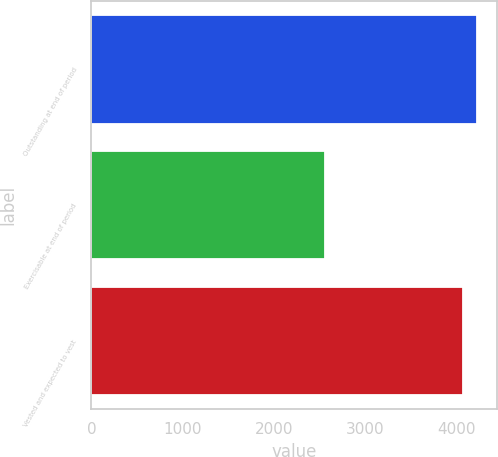Convert chart. <chart><loc_0><loc_0><loc_500><loc_500><bar_chart><fcel>Outstanding at end of period<fcel>Exercisable at end of period<fcel>Vested and expected to vest<nl><fcel>4227.4<fcel>2560<fcel>4072<nl></chart> 